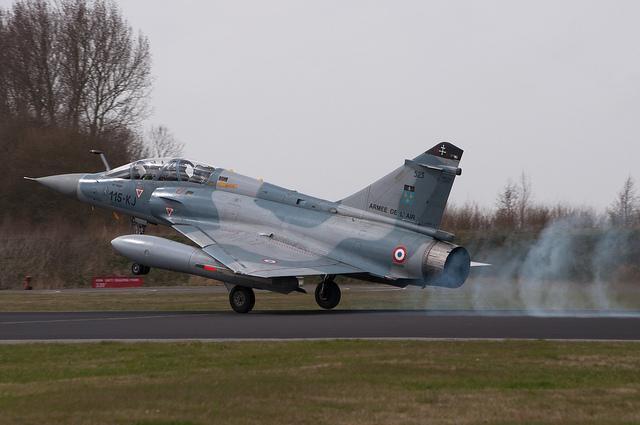How many wheels are on the ground?
Give a very brief answer. 2. 